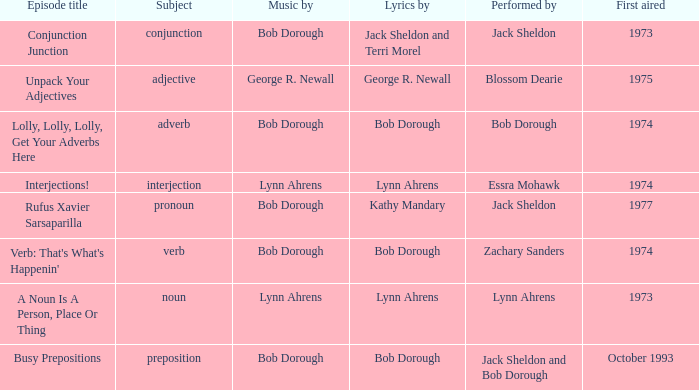When zachary sanders is the entertainer, how many persons is the music created by? 1.0. 